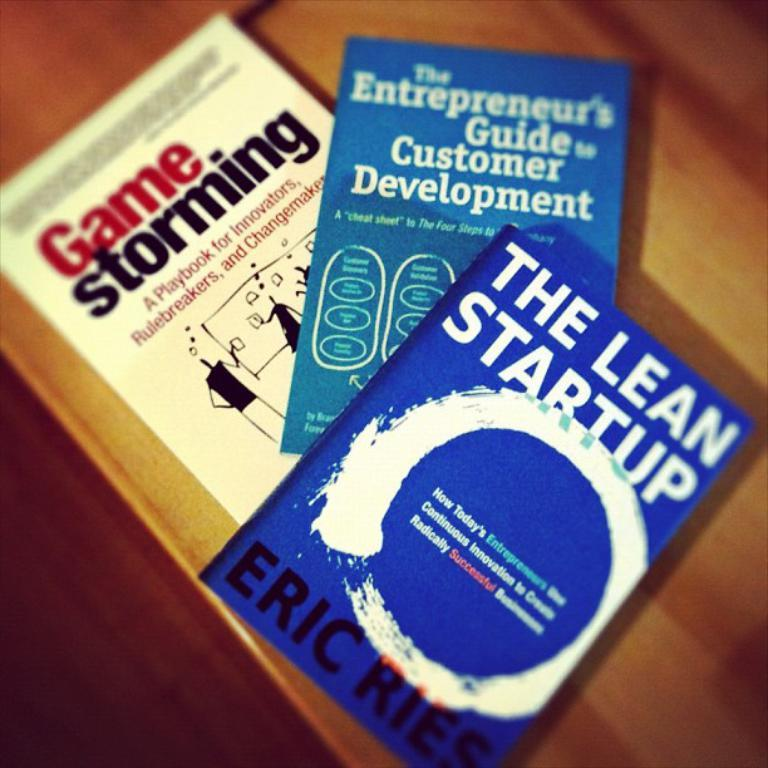Provide a one-sentence caption for the provided image. THREE PAPER BACK BOOKS WITH THE TOP ONE WRITTEN BY ERIC RIES. 